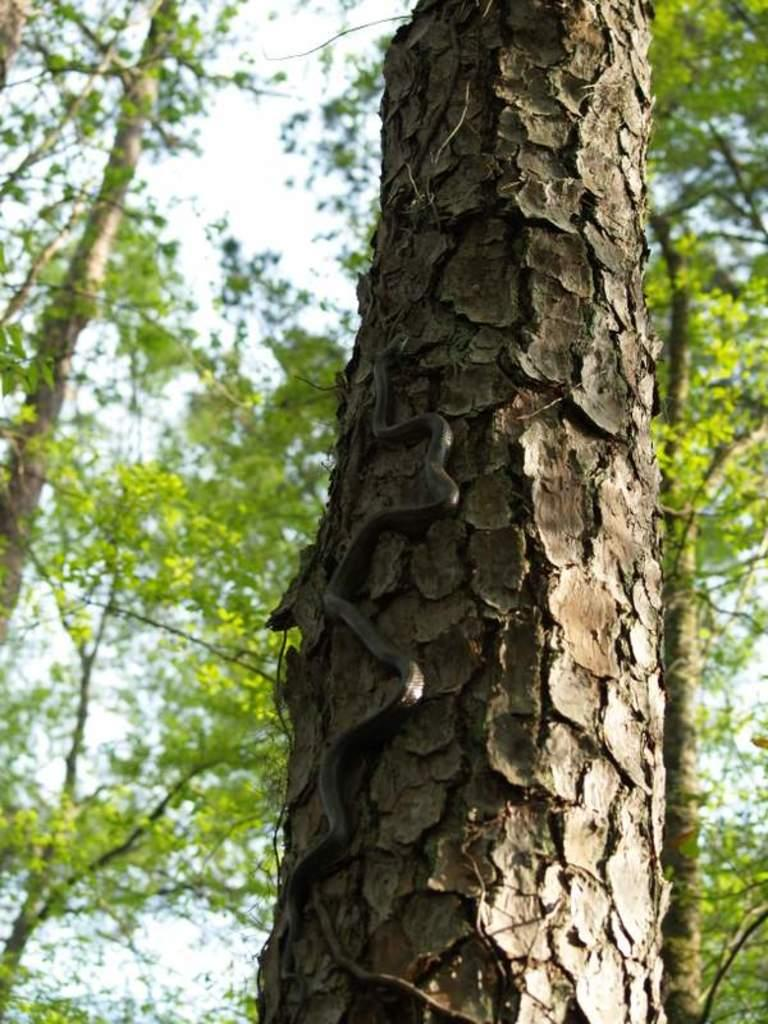What is the main subject of the image? The main subject of the image is a tree trunk. Is there anything else on the tree trunk? Yes, there is a black-colored snake on the tree trunk. What can be seen in the background of the image? There are multiple trees visible in the background of the image. What is the snake's income in the image? There is no information about the snake's income in the image, as snakes do not have incomes. 